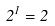<formula> <loc_0><loc_0><loc_500><loc_500>2 ^ { 1 } = 2</formula> 